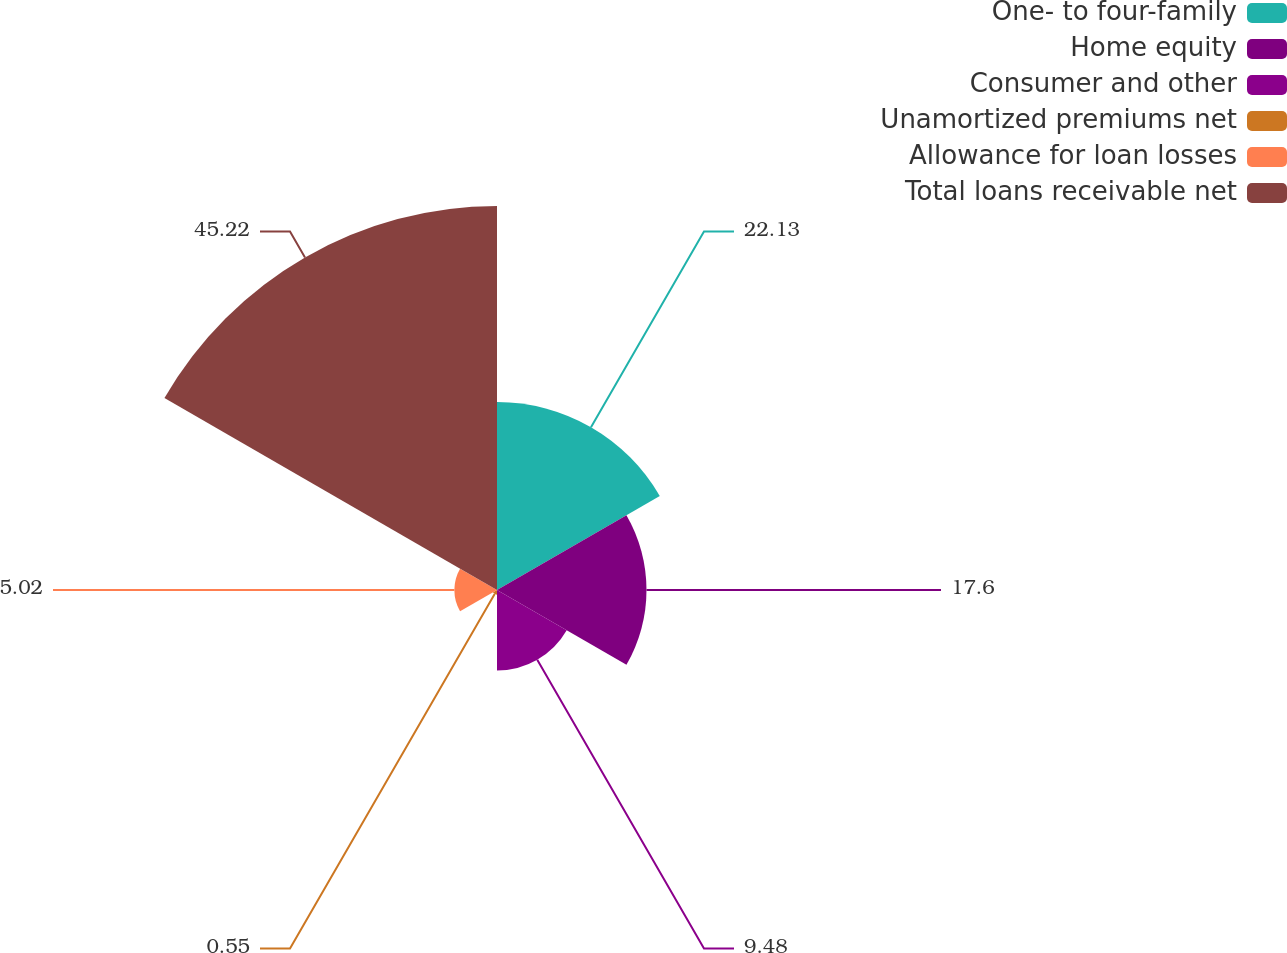Convert chart to OTSL. <chart><loc_0><loc_0><loc_500><loc_500><pie_chart><fcel>One- to four-family<fcel>Home equity<fcel>Consumer and other<fcel>Unamortized premiums net<fcel>Allowance for loan losses<fcel>Total loans receivable net<nl><fcel>22.13%<fcel>17.6%<fcel>9.48%<fcel>0.55%<fcel>5.02%<fcel>45.21%<nl></chart> 